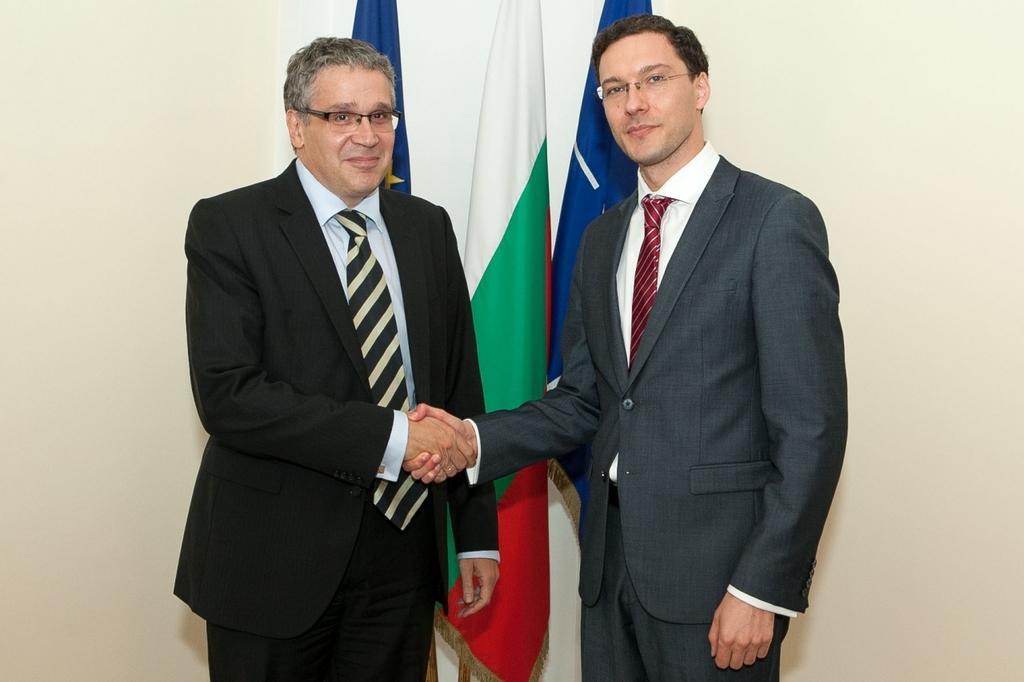Describe this image in one or two sentences. In this image I can see two men wearing suits, standing, shaking their hands, smiling and giving pose for the picture. At the back of these people there are three flags. In the background, I can see the wall. 